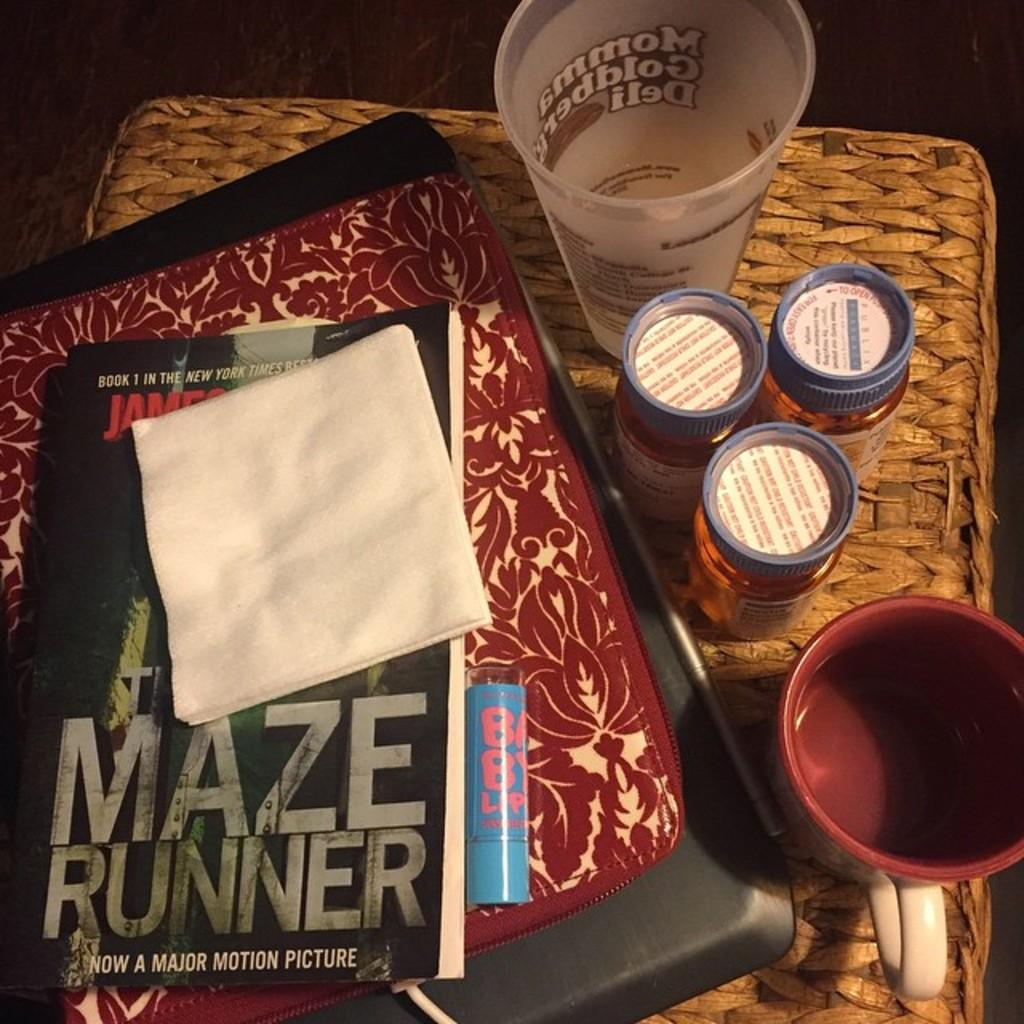<image>
Provide a brief description of the given image. The Maze Runner book has a napkin on it. 